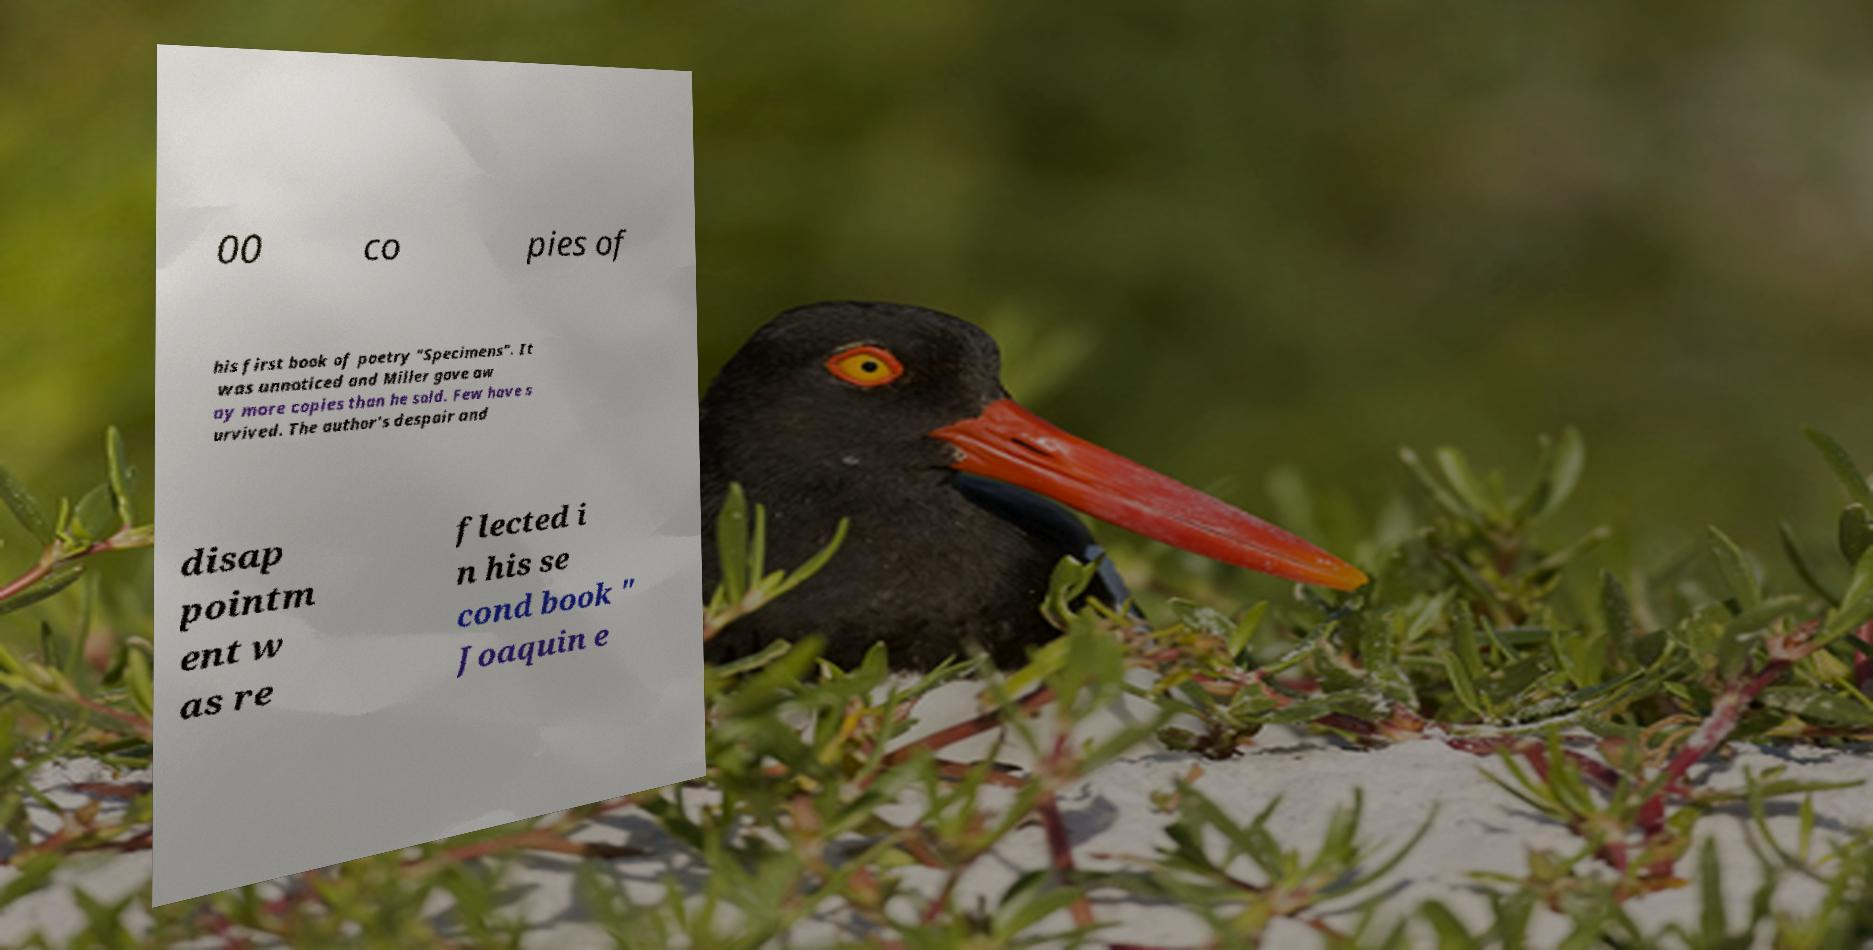Please identify and transcribe the text found in this image. 00 co pies of his first book of poetry "Specimens". It was unnoticed and Miller gave aw ay more copies than he sold. Few have s urvived. The author's despair and disap pointm ent w as re flected i n his se cond book " Joaquin e 